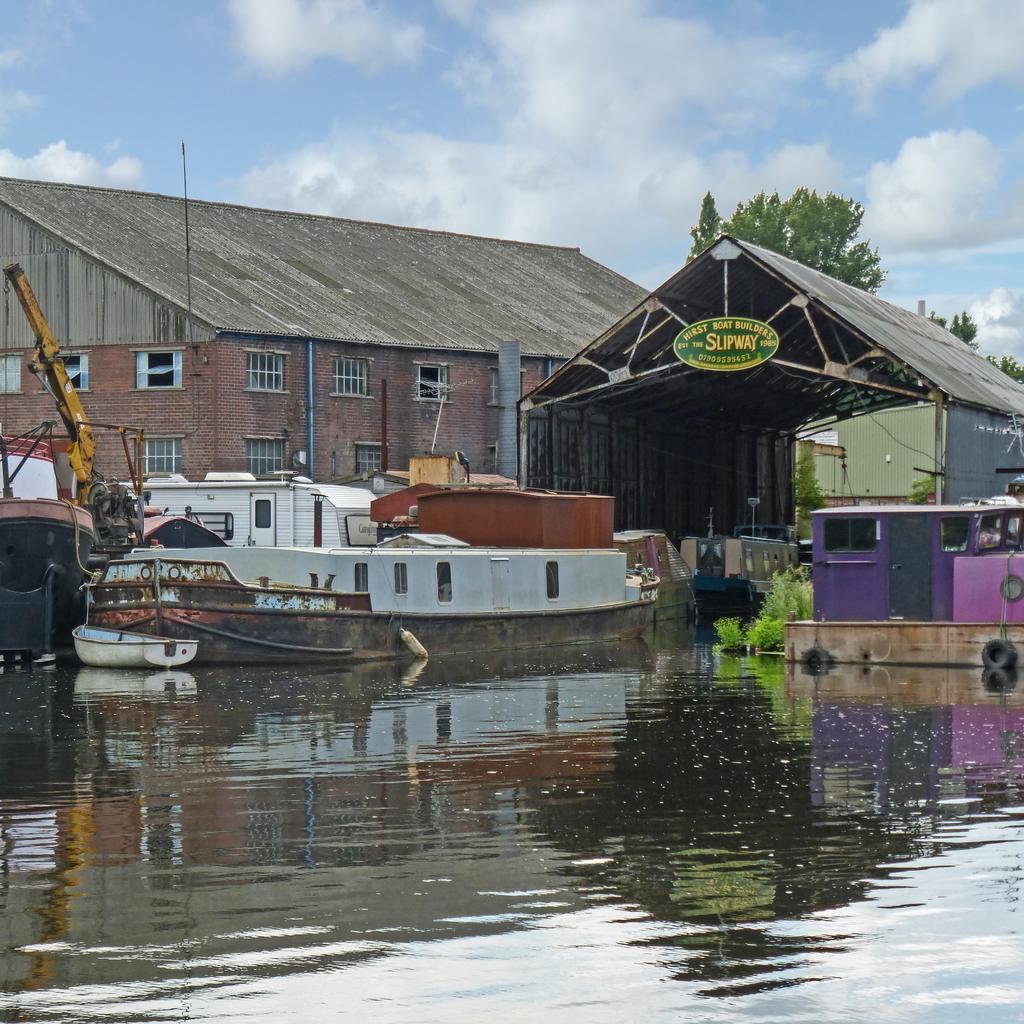How would you summarize this image in a sentence or two? In the picture we can see water and in it we can see some boats and behind it, we can see a shed with a name to it and beside it, we can see building with some windows and behind it we can see a tree, sky with clouds. 